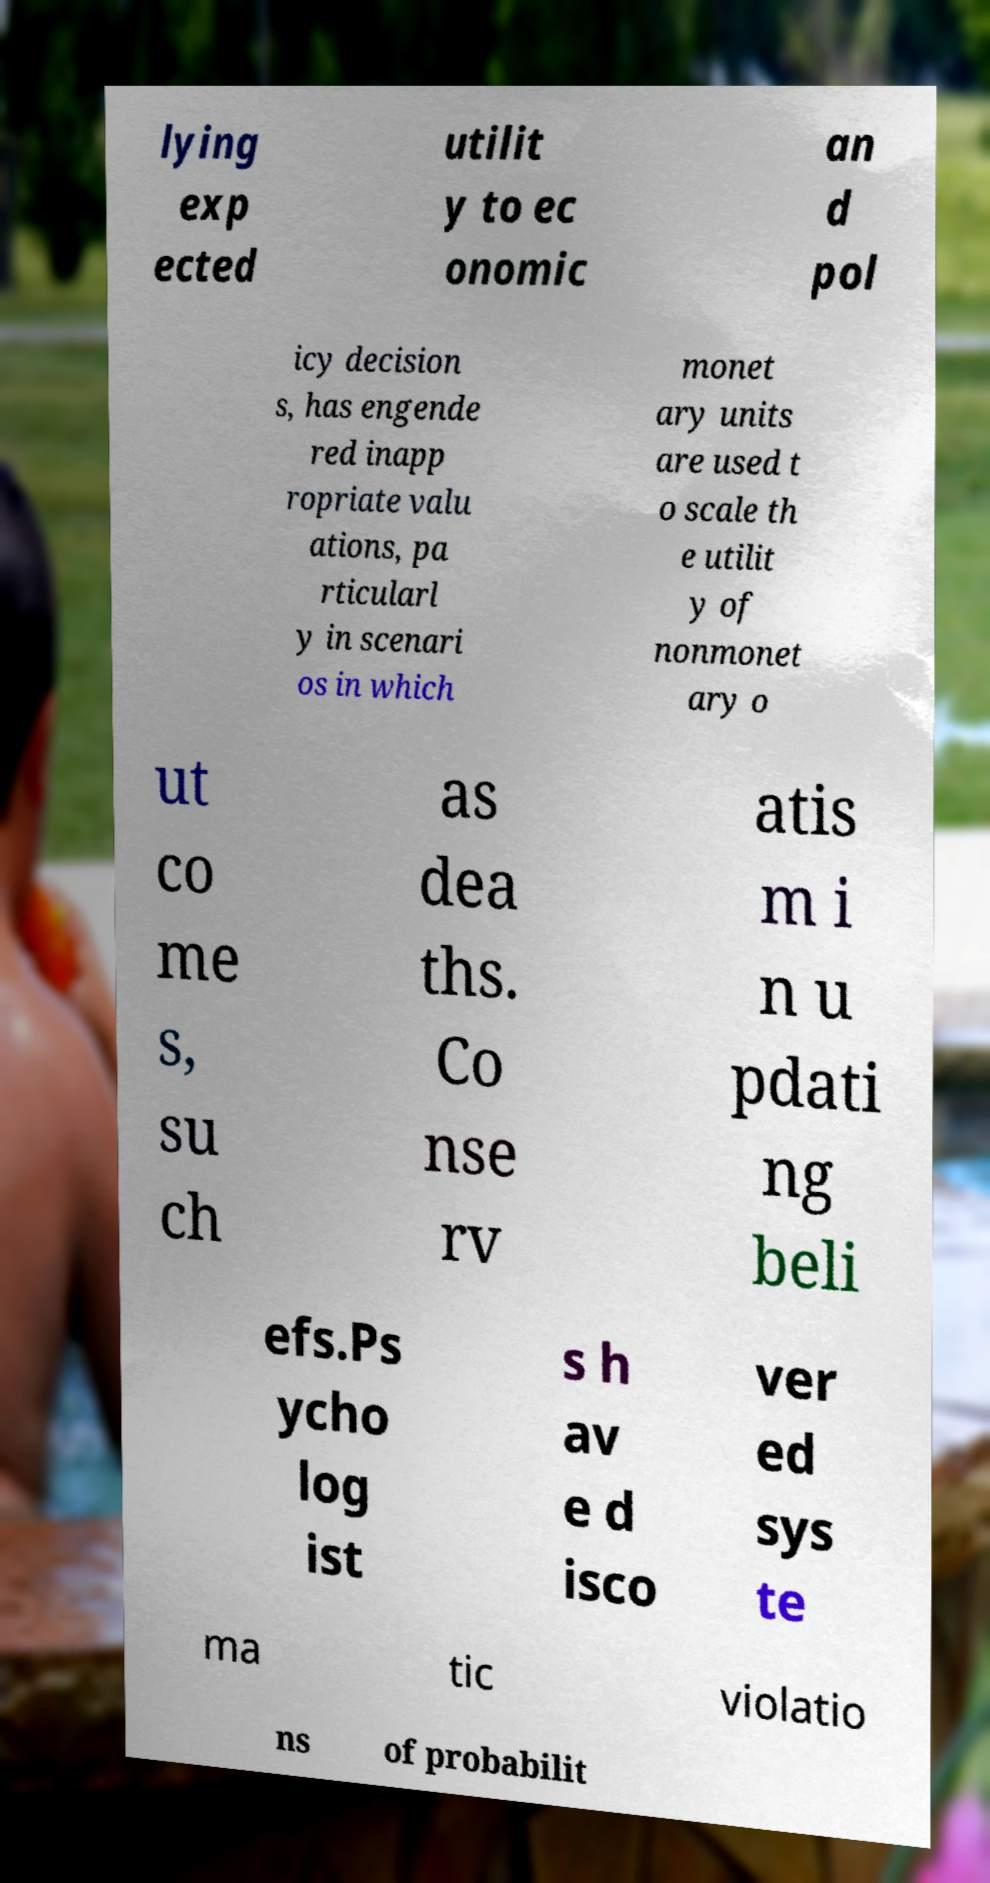What messages or text are displayed in this image? I need them in a readable, typed format. lying exp ected utilit y to ec onomic an d pol icy decision s, has engende red inapp ropriate valu ations, pa rticularl y in scenari os in which monet ary units are used t o scale th e utilit y of nonmonet ary o ut co me s, su ch as dea ths. Co nse rv atis m i n u pdati ng beli efs.Ps ycho log ist s h av e d isco ver ed sys te ma tic violatio ns of probabilit 